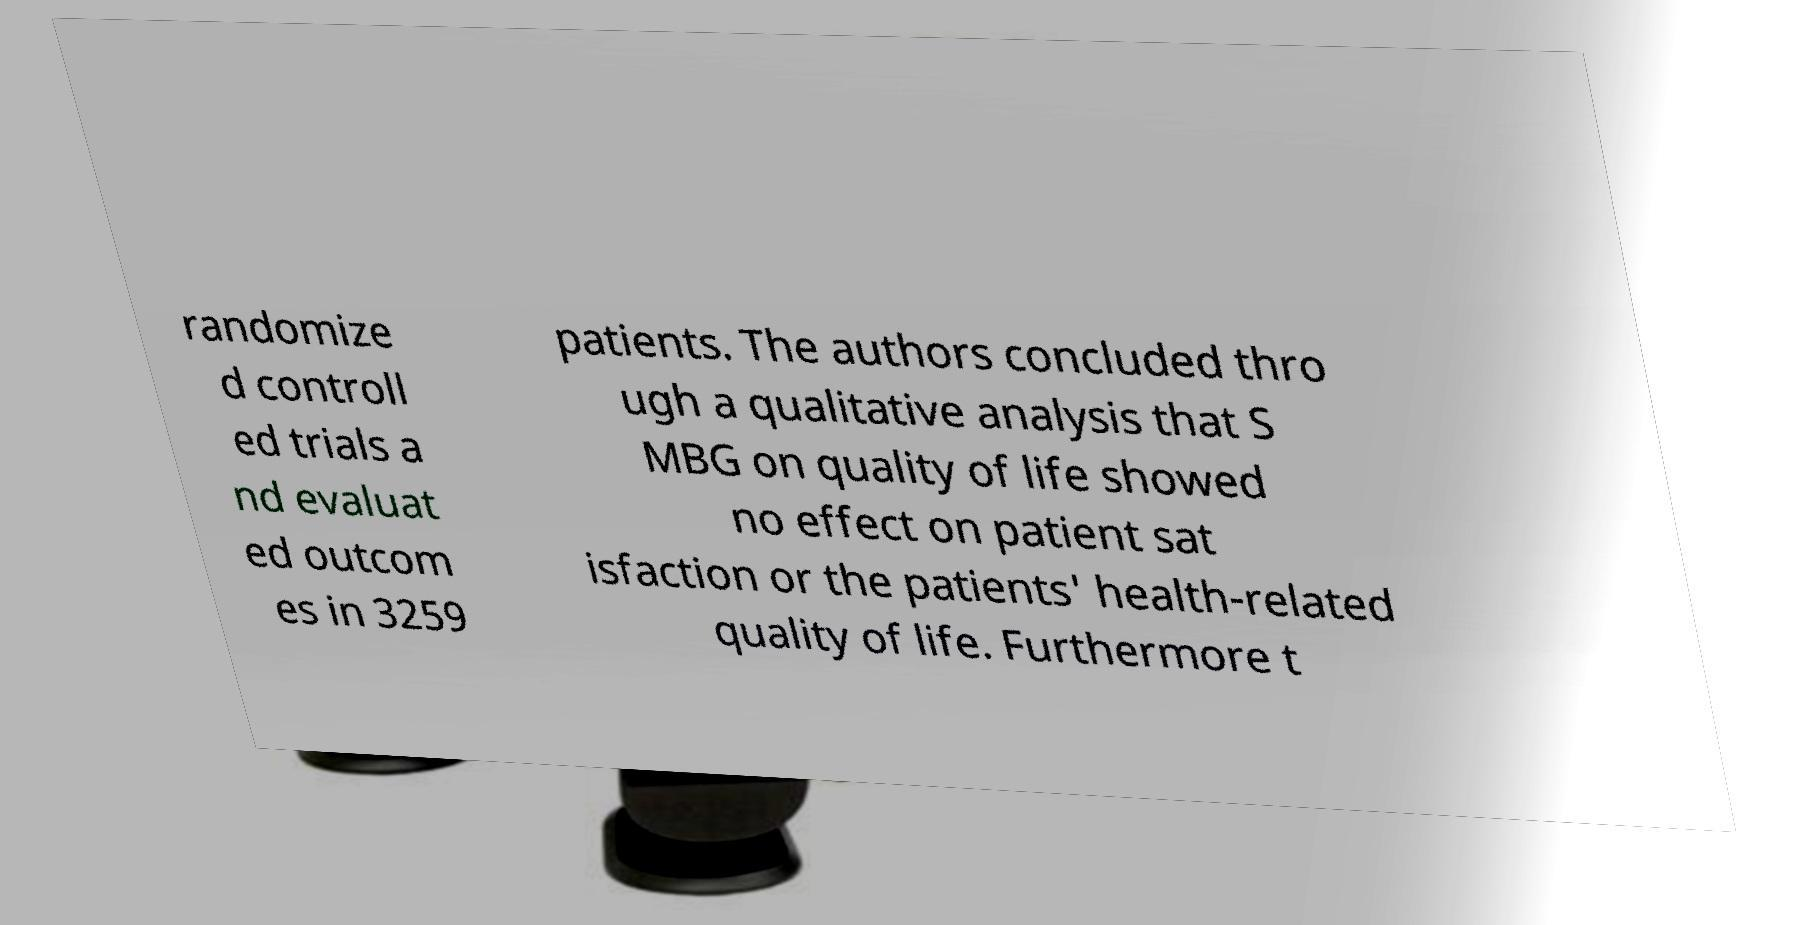Can you accurately transcribe the text from the provided image for me? randomize d controll ed trials a nd evaluat ed outcom es in 3259 patients. The authors concluded thro ugh a qualitative analysis that S MBG on quality of life showed no effect on patient sat isfaction or the patients' health-related quality of life. Furthermore t 